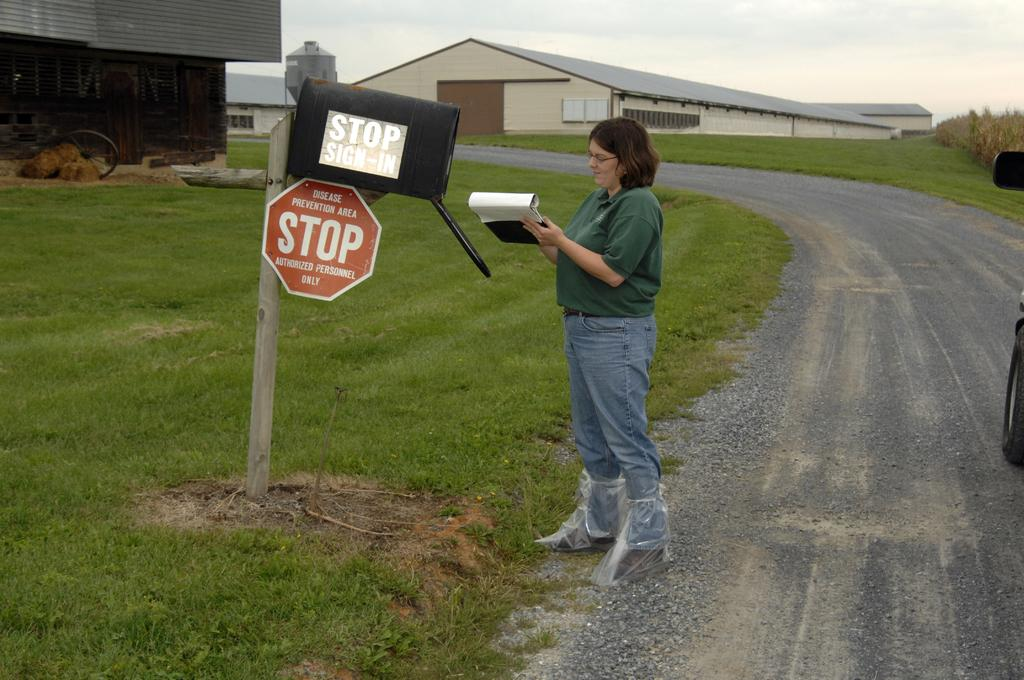<image>
Share a concise interpretation of the image provided. The stop sign states that is area is for authorized personnel only. 